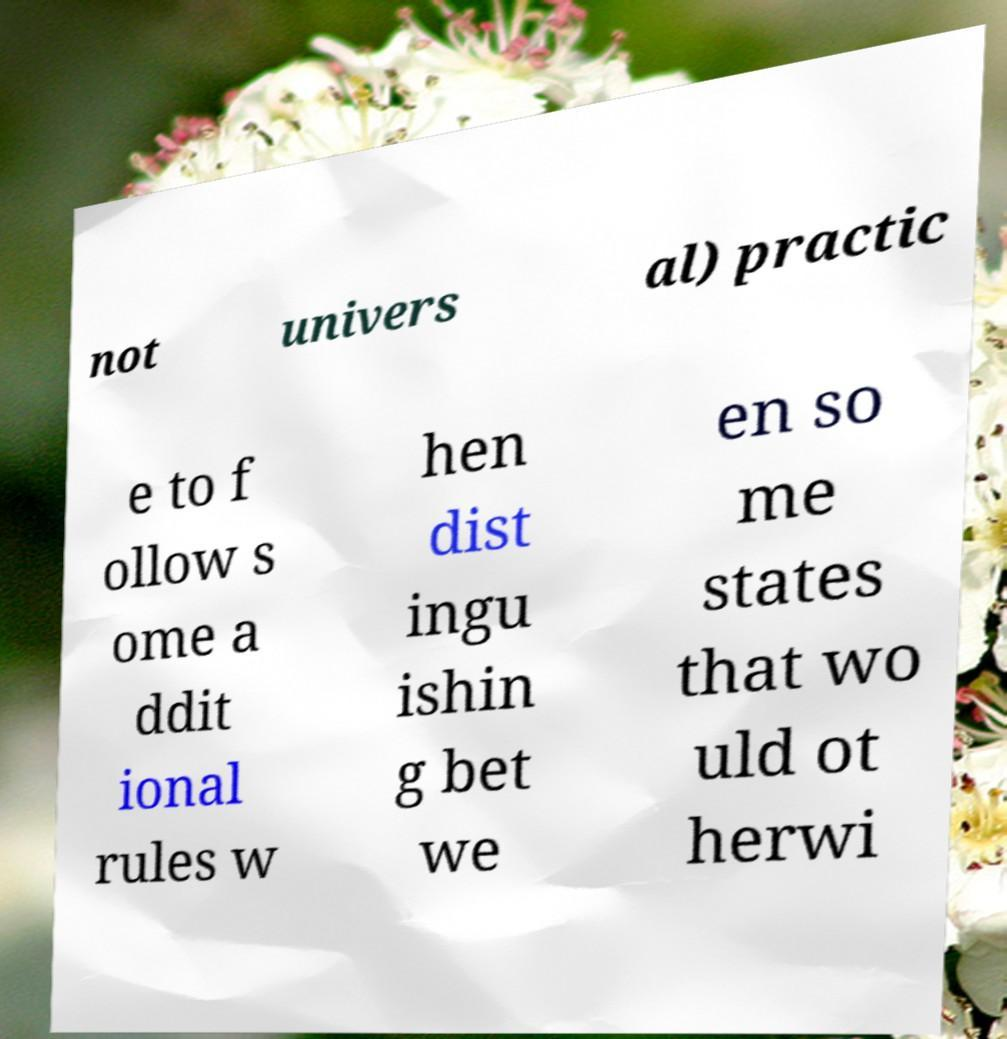Can you read and provide the text displayed in the image?This photo seems to have some interesting text. Can you extract and type it out for me? not univers al) practic e to f ollow s ome a ddit ional rules w hen dist ingu ishin g bet we en so me states that wo uld ot herwi 